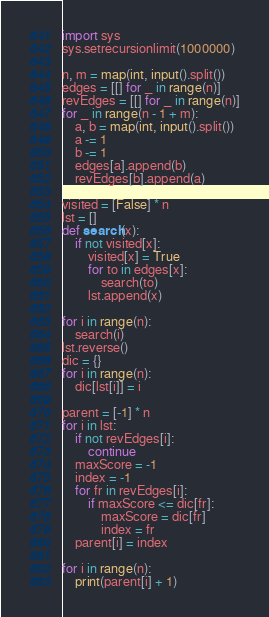Convert code to text. <code><loc_0><loc_0><loc_500><loc_500><_Python_>import sys
sys.setrecursionlimit(1000000)

n, m = map(int, input().split())
edges = [[] for _ in range(n)]
revEdges = [[] for _ in range(n)]
for _ in range(n - 1 + m):
    a, b = map(int, input().split())
    a -= 1
    b -= 1
    edges[a].append(b)
    revEdges[b].append(a)

visited = [False] * n
lst = []
def search(x):
    if not visited[x]:
        visited[x] = True
        for to in edges[x]:
            search(to)
        lst.append(x)

for i in range(n):
    search(i)
lst.reverse()
dic = {}
for i in range(n):
    dic[lst[i]] = i

parent = [-1] * n
for i in lst:
    if not revEdges[i]:
        continue
    maxScore = -1
    index = -1
    for fr in revEdges[i]:
        if maxScore <= dic[fr]:
            maxScore = dic[fr]
            index = fr
    parent[i] = index

for i in range(n):
    print(parent[i] + 1)</code> 